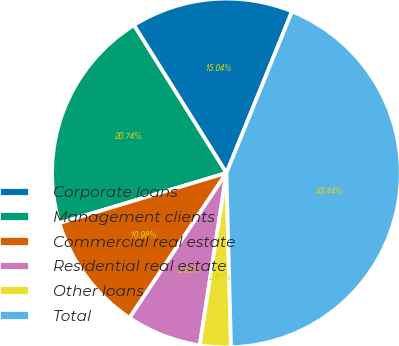Convert chart. <chart><loc_0><loc_0><loc_500><loc_500><pie_chart><fcel>Corporate loans<fcel>Management clients<fcel>Commercial real estate<fcel>Residential real estate<fcel>Other loans<fcel>Total<nl><fcel>15.04%<fcel>20.74%<fcel>10.98%<fcel>6.93%<fcel>2.87%<fcel>43.44%<nl></chart> 